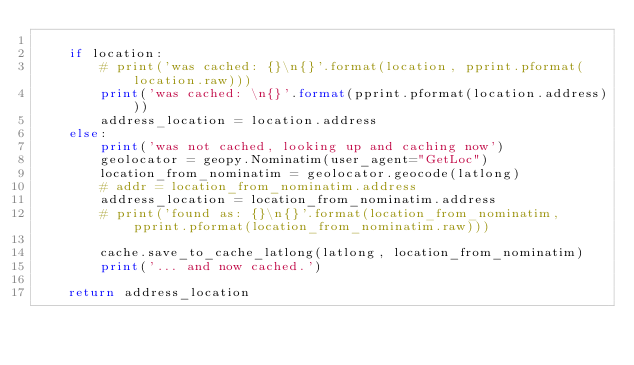<code> <loc_0><loc_0><loc_500><loc_500><_Python_>
    if location:
        # print('was cached: {}\n{}'.format(location, pprint.pformat(location.raw)))
        print('was cached: \n{}'.format(pprint.pformat(location.address)))
        address_location = location.address
    else:
        print('was not cached, looking up and caching now')
        geolocator = geopy.Nominatim(user_agent="GetLoc")
        location_from_nominatim = geolocator.geocode(latlong)
        # addr = location_from_nominatim.address
        address_location = location_from_nominatim.address
        # print('found as: {}\n{}'.format(location_from_nominatim, pprint.pformat(location_from_nominatim.raw)))

        cache.save_to_cache_latlong(latlong, location_from_nominatim)
        print('... and now cached.')

    return address_location
</code> 